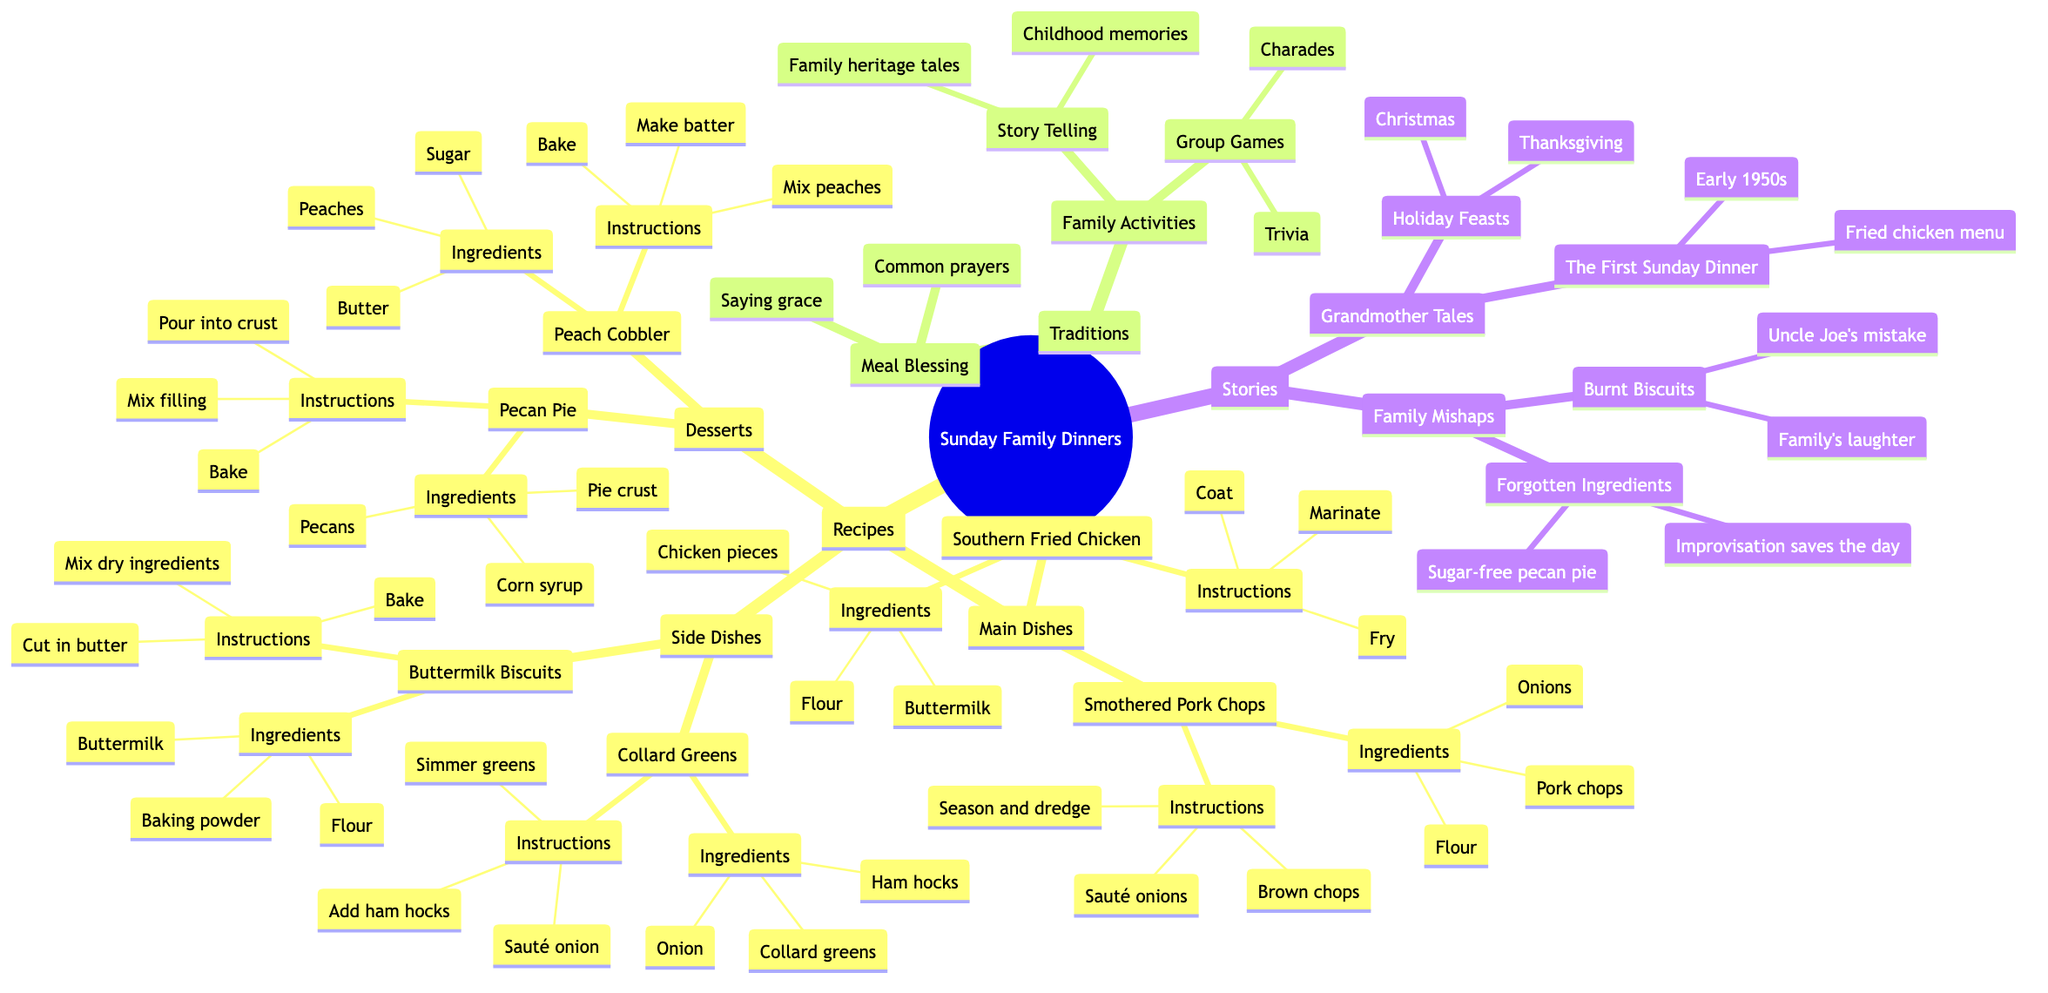What are the two main categories under Recipes? By examining the diagram, I can see that the main categories under Recipes are "Main Dishes" and "Side Dishes". These are hierarchical nodes directly stemming from the Recipes node.
Answer: Main Dishes, Side Dishes How many types of desserts are listed? Looking at the Desserts section, I count two types: "Peach Cobbler" and "Pecan Pie". These are the only items under the dessert category.
Answer: 2 What common prayer is listed under Meal Blessing? The diagram mentions specific common prayers associated with Meal Blessing. One of them is "God is great, God is good...". Since it is explicitly stated under that node, that is the answer.
Answer: God is great, God is good.. Which dish involves marinating chicken? Under the "Main Dishes" section for Southern Fried Chicken, it is specified that the chicken must be marinated in buttermilk, indicating the preparation method. This tells me it is the dish that involves marinating chicken.
Answer: Southern Fried Chicken What family activity is described as sharing stories? Under Family Activities, the section labeled Story Telling indicates it focuses on sharing family stories and anecdotes. This is a direct connection in the diagram.
Answer: Story Telling What incident involved Uncle Joe? In the Family Mishaps section, the incident concerning "Burnt Biscuits" mentions Uncle Joe as being responsible for the mistake, which is captured in the diagram under that node.
Answer: Burnt Biscuits How was improvisation used in forgotten ingredient stories? The Forgotten Ingredients story highlights an instance where "the time the sugar was left out of the pecan pie" occurred. It also mentions "How improvisation saved the day", revealing a clever solution to the problem, which directly relates to the story.
Answer: Improvisation saves the day What is the summary of "The First Sunday Dinner"? The Grandmother Tales section presents a summary indicating "The history of the first ever Sunday dinner hosted by the grandmother". This summary is explicitly detailed under that node within the diagram.
Answer: The history of the first ever Sunday dinner hosted by the grandmother Which game is commonly played after meals? The diagram lists "Charades" as one of the common games played under Family Activities -> Group Games, indicating that this game is a familiar choice for activities after meals.
Answer: Charades 